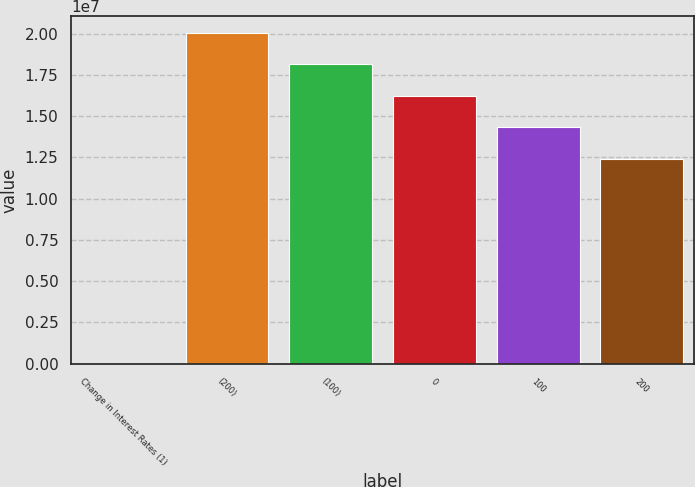Convert chart. <chart><loc_0><loc_0><loc_500><loc_500><bar_chart><fcel>Change in Interest Rates (1)<fcel>(200)<fcel>(100)<fcel>0<fcel>100<fcel>200<nl><fcel>2016<fcel>2.00453e+07<fcel>1.81329e+07<fcel>1.62205e+07<fcel>1.43081e+07<fcel>1.23956e+07<nl></chart> 